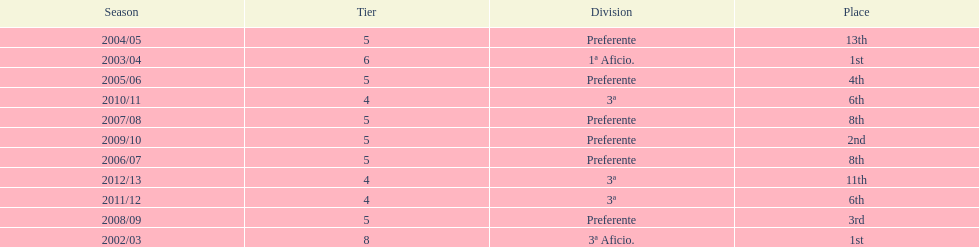Which division has the largest number of ranks? Preferente. 